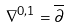<formula> <loc_0><loc_0><loc_500><loc_500>\nabla ^ { 0 , 1 } = \overline { \partial }</formula> 